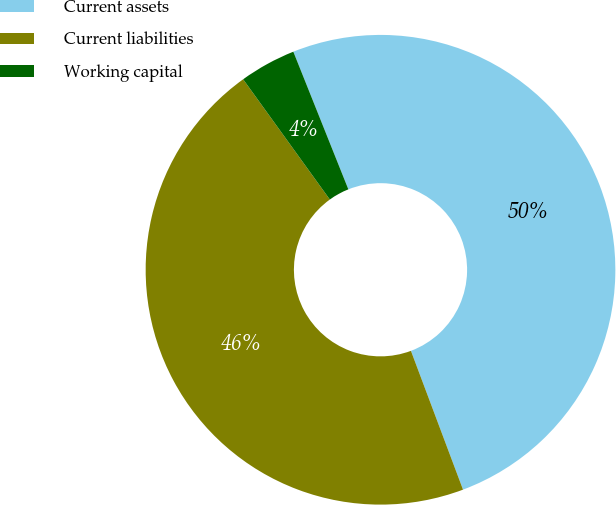Convert chart to OTSL. <chart><loc_0><loc_0><loc_500><loc_500><pie_chart><fcel>Current assets<fcel>Current liabilities<fcel>Working capital<nl><fcel>50.34%<fcel>45.77%<fcel>3.89%<nl></chart> 